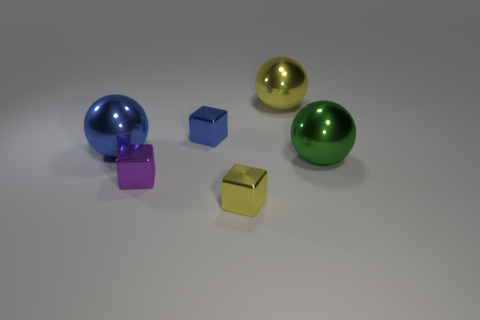Is the size of the metallic sphere that is to the left of the yellow shiny block the same as the purple metal cube?
Offer a terse response. No. What number of blue metal blocks are there?
Offer a very short reply. 1. What color is the object that is to the left of the small blue object and behind the purple cube?
Ensure brevity in your answer.  Blue. There is a large blue metallic thing; are there any purple objects on the left side of it?
Your answer should be compact. No. What number of big things are to the left of the yellow thing that is behind the tiny purple metallic block?
Your answer should be compact. 1. The green sphere that is made of the same material as the purple object is what size?
Provide a short and direct response. Large. What size is the blue metallic cube?
Ensure brevity in your answer.  Small. What number of cubes are small blue metal objects or large metal things?
Your response must be concise. 1. What is the color of the big ball on the left side of the blue thing on the right side of the blue ball?
Your answer should be very brief. Blue. There is a tiny yellow shiny block in front of the yellow shiny object that is behind the large blue object; how many blue objects are behind it?
Keep it short and to the point. 2. 